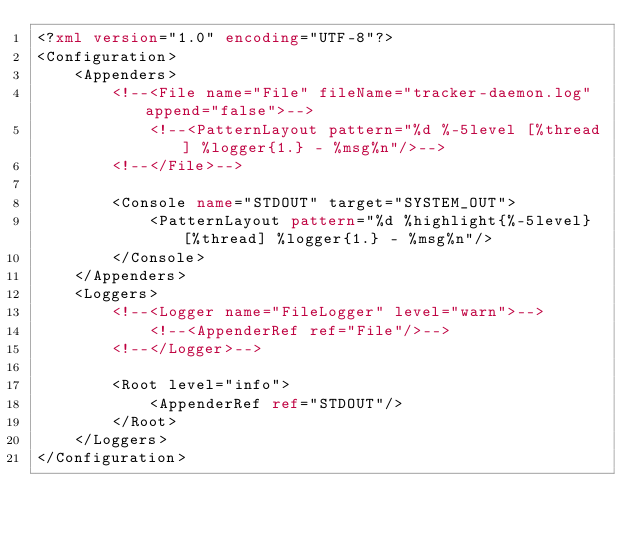Convert code to text. <code><loc_0><loc_0><loc_500><loc_500><_XML_><?xml version="1.0" encoding="UTF-8"?>
<Configuration>
    <Appenders>
        <!--<File name="File" fileName="tracker-daemon.log" append="false">-->
            <!--<PatternLayout pattern="%d %-5level [%thread] %logger{1.} - %msg%n"/>-->
        <!--</File>-->

        <Console name="STDOUT" target="SYSTEM_OUT">
            <PatternLayout pattern="%d %highlight{%-5level} [%thread] %logger{1.} - %msg%n"/>
        </Console>
    </Appenders>
    <Loggers>
        <!--<Logger name="FileLogger" level="warn">-->
            <!--<AppenderRef ref="File"/>-->
        <!--</Logger>-->

        <Root level="info">
            <AppenderRef ref="STDOUT"/>
        </Root>
    </Loggers>
</Configuration>
</code> 